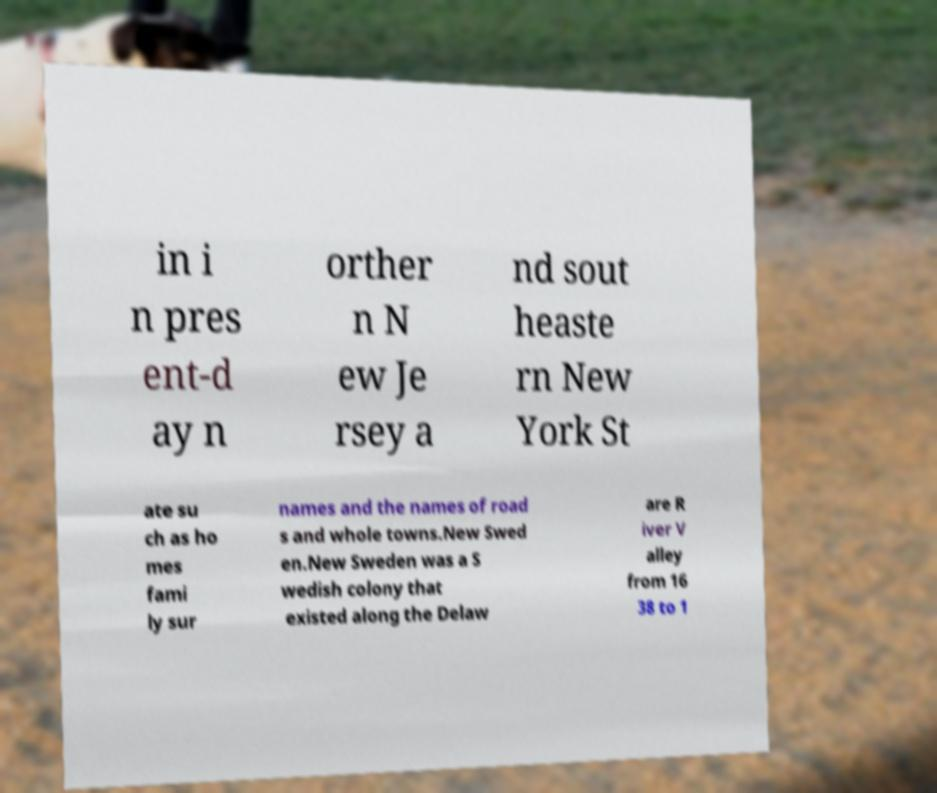Could you extract and type out the text from this image? in i n pres ent-d ay n orther n N ew Je rsey a nd sout heaste rn New York St ate su ch as ho mes fami ly sur names and the names of road s and whole towns.New Swed en.New Sweden was a S wedish colony that existed along the Delaw are R iver V alley from 16 38 to 1 